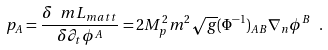Convert formula to latex. <formula><loc_0><loc_0><loc_500><loc_500>p _ { A } = \frac { \delta \ m L _ { m a t t } } { \delta \partial _ { t } \phi ^ { A } } = 2 M _ { p } ^ { 2 } m ^ { 2 } \sqrt { g } ( \Phi ^ { - 1 } ) _ { A B } \nabla _ { n } \phi ^ { B } \ .</formula> 